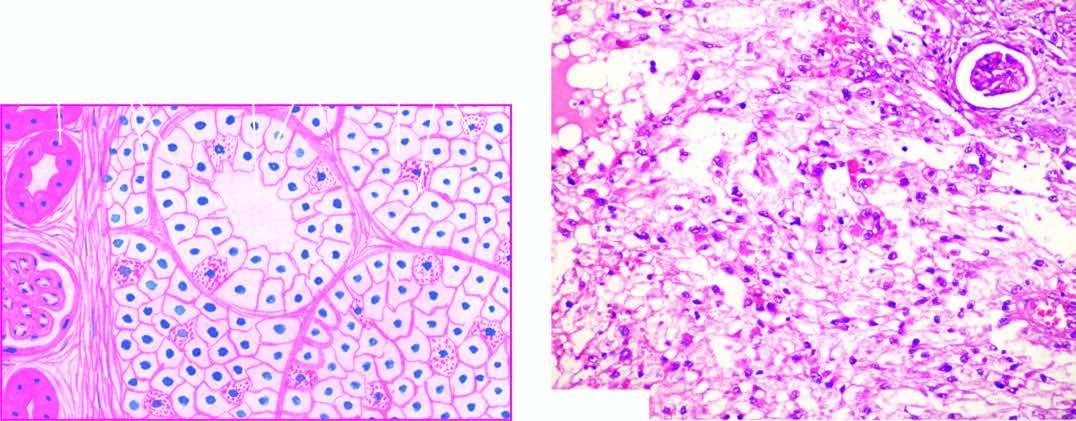what is the stroma composed of?
Answer the question using a single word or phrase. Fine and delicate fibrous tissue 